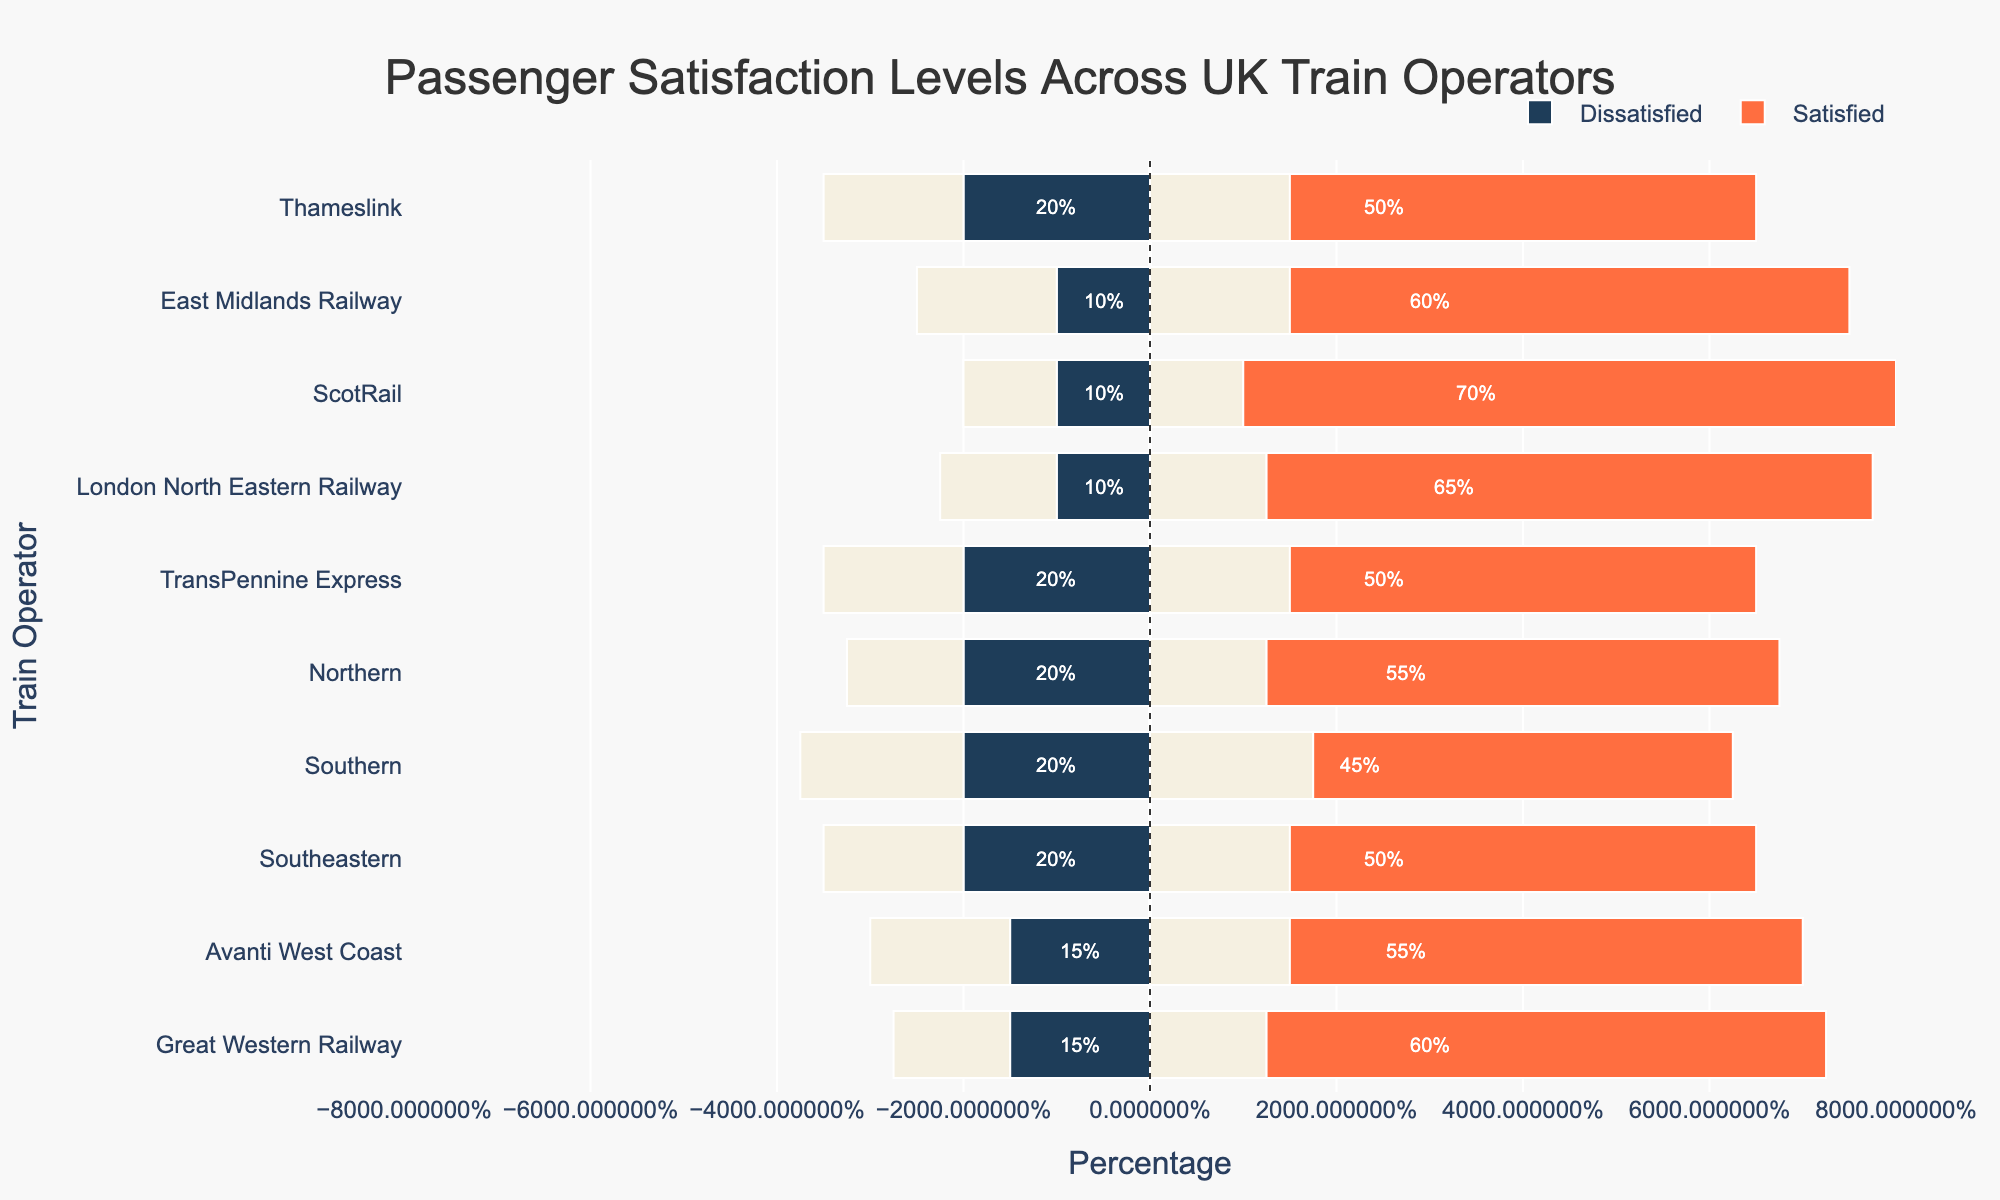Which train operator has the highest percentage of satisfied passengers? To determine which train operator has the highest percentage of satisfied passengers, examine the lengths of the orange bars. The train operator with the longest orange bar represents the highest satisfaction percentage. ScotRail's bar is the longest.
Answer: ScotRail Which train operator has the lowest percentage of dissatisfied passengers? To identify the train operator with the lowest percentage of dissatisfied passengers, look for the shortest blue bar extending to the left. London North Eastern Railway and ScotRail both have short blue bars for dissatisfaction, but ScotRail's bar is slightly smaller.
Answer: ScotRail What is the total percentage of satisfied passengers and neutral passengers for Northern? For Northern, add the satisfied (55%) and neutral (25%) percentages together.
Answer: 80% Compare the satisfied passenger percentages between Great Western Railway and Avanti West Coast. Which one is higher? Look at the lengths of the orange bars for Great Western Railway and Avanti West Coast. Great Western Railway has a satisfaction of 60% and Avanti West Coast has 55%.
Answer: Great Western Railway What is the difference in dissatisfaction percentages between Southeastern and Southern? First, find the dissatisfaction percentages for Southeastern (20%) and Southern (20%). Subtract the two values to find the difference.
Answer: 0% What train operator has the same percentage of neutral passengers as dissatisfied passengers? Examine the values visually and compare the positions of the green and blue sections of each operator's bar. Southern and Thameslink each have both 20% neutral and 20% dissatisfied passengers.
Answer: Southern and Thameslink What is the combined percentage of satisfied and dissatisfied passengers for London North Eastern Railway? Add the satisfied percentage (65%) and the dissatisfied percentage (10%) together.
Answer: 75% Which train operators have an equal percentage of satisfied and neutral passengers? Compare the lengths of the orange and green bars for each train operator. None of the operators have equal lengths for these two categories.
Answer: None What is the average satisfaction level across all train operators? Sum all the satisfied percentages: (60 + 55 + 50 + 45 + 55 + 50 + 65 + 70 + 60 + 50) = 560. Then divide by the number of operators, which is 10. The average is 560/10.
Answer: 56% For Thameslink, what percentage of passengers are either neutral or dissatisfied? Add the neutral (30%) and dissatisfied (20%) percentages together for Thameslink. 30% + 20% = 50%.
Answer: 50% 